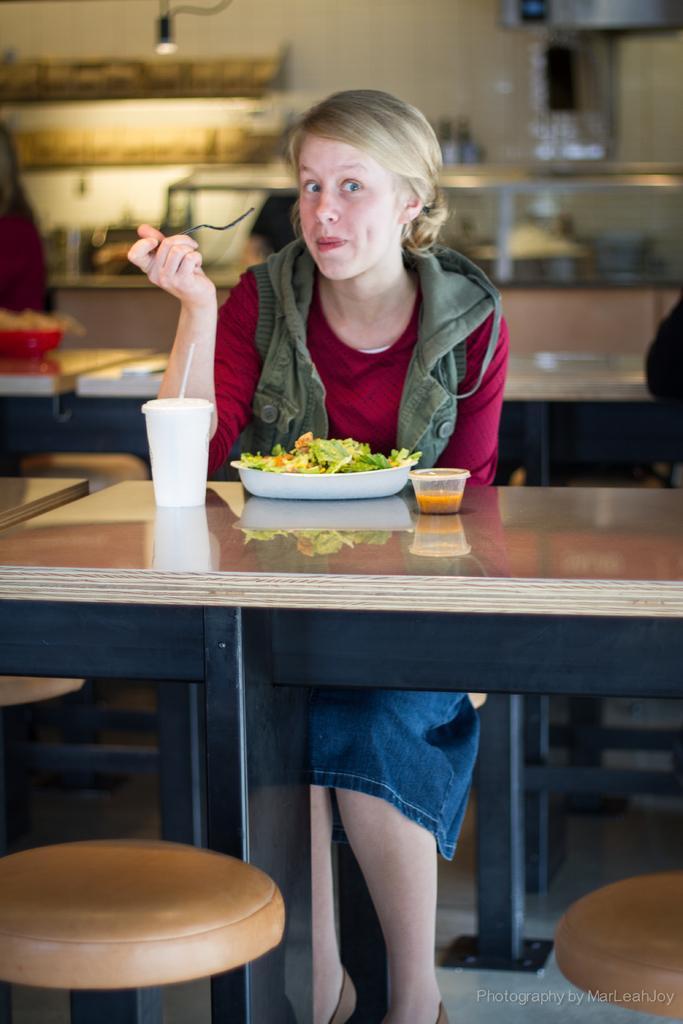Please provide a concise description of this image. In this image I can see a woman is sitting and I can see she is holding a fork. I can also see she is wearing a jacket, a red top and in the front of her I can see a table and two stools. On the table I can see a glass, a plate, a cup and food in the plate. In the background I can see few more tables, one person, number of things and I can also see this is little bit blurry. 